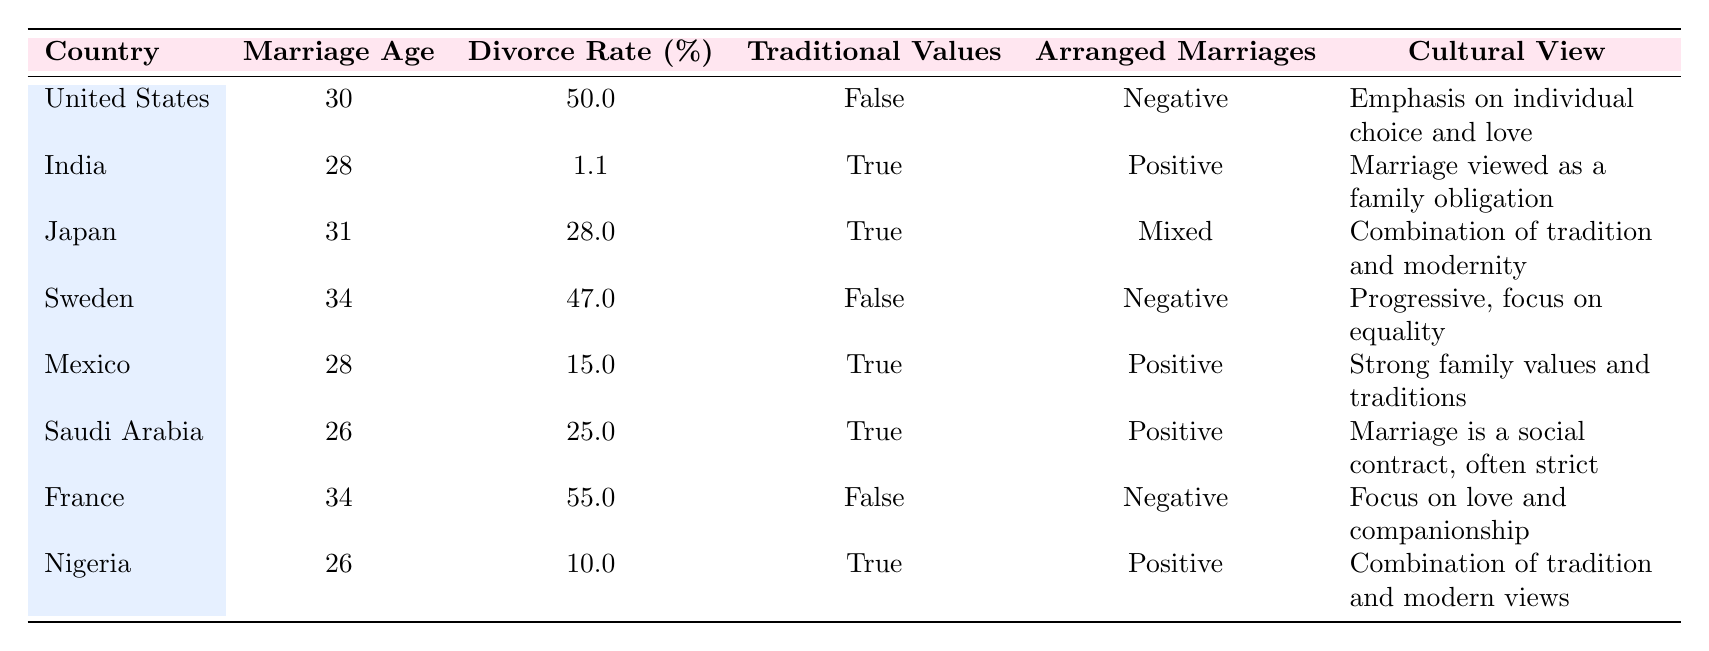What is the divorce rate in India? Referring to the table, the divorce rate for India is specifically stated in its row. The value is 1.1%.
Answer: 1.1% Which country has the highest divorce rate? By looking at the divorce rates listed in the table, the country with the highest divorce rate is France at 55%.
Answer: France Is traditional values in Saudi Arabia true or false? According to the table, the value under traditional values for Saudi Arabia is listed as true.
Answer: True What is the average marriage age across these countries? To find the average marriage age, sum the marriage ages of all countries: (30 + 28 + 31 + 34 + 28 + 26 + 34 + 26) =  7 countries totaling  233. Then divide by 8: 233/8 = 29.125.
Answer: 29.125 Do countries with traditional values generally have negative views on arranged marriages? The countries with traditional values are India, Japan, Mexico, Saudi Arabia, and Nigeria. Their views on arranged marriages are mixed or positive; hence it's inaccurate to say they generally have negative views.
Answer: No How many countries have a divorce rate below 15%? The countries with a divorce rate below 15% are India (1.1%), Mexico (15%), and Nigeria (10%). This totals three countries.
Answer: 3 Which country has a positive view on arranged marriages but a higher divorce rate than Nigeria? According to the table, Nigeria has a divorce rate of 10%. The countries with a positive view on arranged marriages and a higher divorce rate than Nigeria are Saudi Arabia (25%).
Answer: Saudi Arabia What is the difference in marriage age between Sweden and Saudi Arabia? The marriage age for Sweden is 34 and for Saudi Arabia, it is 26. To find the difference: 34 - 26 = 8.
Answer: 8 